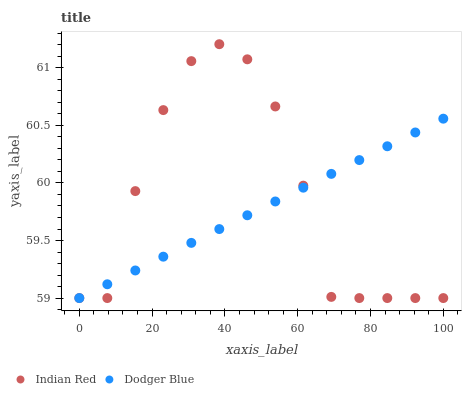Does Dodger Blue have the minimum area under the curve?
Answer yes or no. Yes. Does Indian Red have the maximum area under the curve?
Answer yes or no. Yes. Does Indian Red have the minimum area under the curve?
Answer yes or no. No. Is Dodger Blue the smoothest?
Answer yes or no. Yes. Is Indian Red the roughest?
Answer yes or no. Yes. Is Indian Red the smoothest?
Answer yes or no. No. Does Dodger Blue have the lowest value?
Answer yes or no. Yes. Does Indian Red have the highest value?
Answer yes or no. Yes. Does Dodger Blue intersect Indian Red?
Answer yes or no. Yes. Is Dodger Blue less than Indian Red?
Answer yes or no. No. Is Dodger Blue greater than Indian Red?
Answer yes or no. No. 